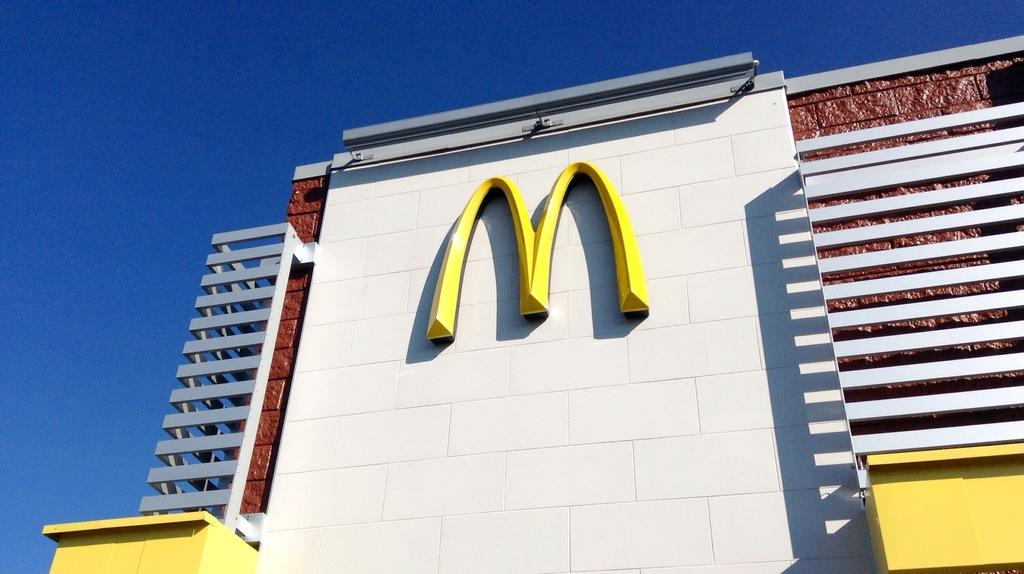What type of structure is visible in the image? There is a building in the image. What company is associated with the building? The building has a McDonald's logo. What is the weather like in the image? The sky is clear, and it is sunny in the image. Can you see any pigs running away from the building in the image? There are no pigs present in the image, and therefore no such activity can be observed. 